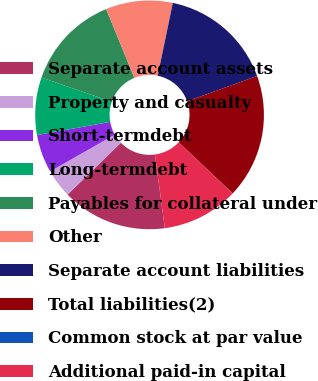Convert chart. <chart><loc_0><loc_0><loc_500><loc_500><pie_chart><fcel>Separate account assets<fcel>Property and casualty<fcel>Short-termdebt<fcel>Long-termdebt<fcel>Payables for collateral under<fcel>Other<fcel>Separate account liabilities<fcel>Total liabilities(2)<fcel>Common stock at par value<fcel>Additional paid-in capital<nl><fcel>14.86%<fcel>4.05%<fcel>5.41%<fcel>8.11%<fcel>13.51%<fcel>9.46%<fcel>16.22%<fcel>17.57%<fcel>0.0%<fcel>10.81%<nl></chart> 